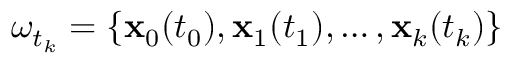<formula> <loc_0><loc_0><loc_500><loc_500>\omega _ { t _ { k } } = \{ x _ { 0 } ( t _ { 0 } ) , x _ { 1 } ( t _ { 1 } ) , \dots , x _ { k } ( t _ { k } ) \}</formula> 